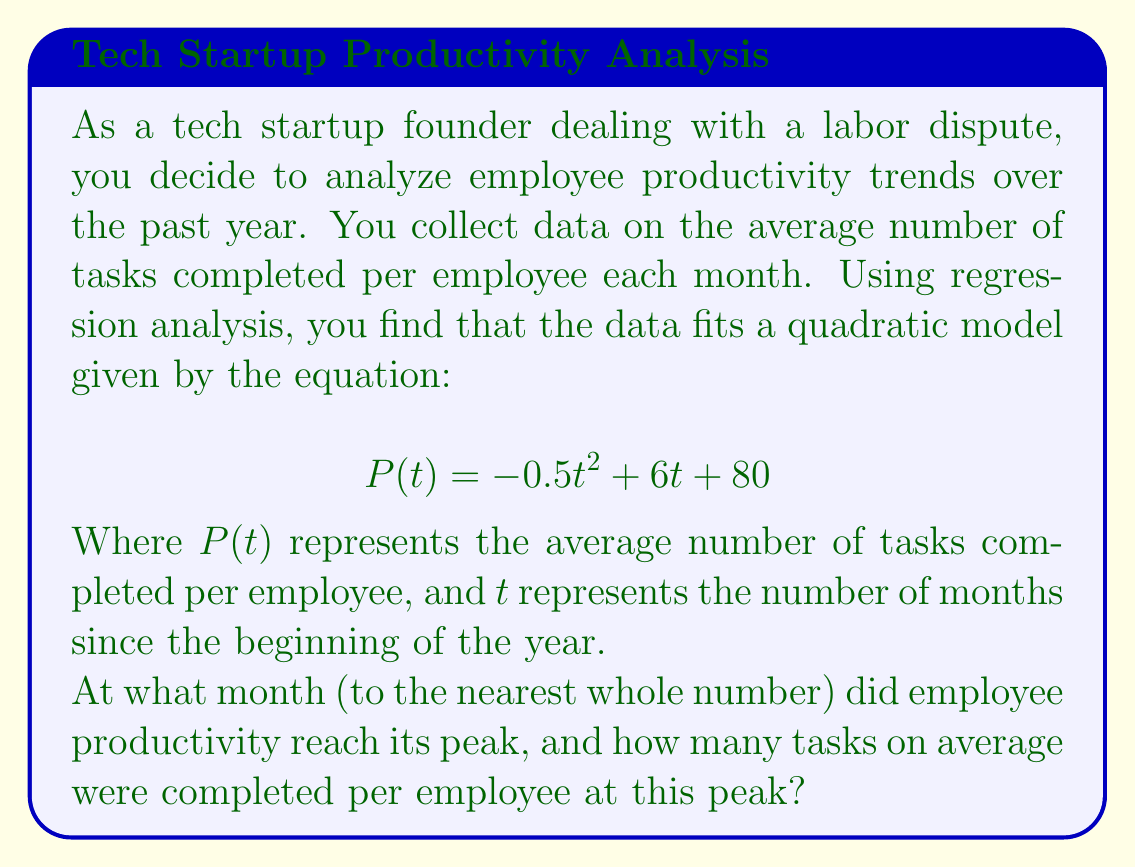Provide a solution to this math problem. To solve this problem, we need to follow these steps:

1. Find the vertex of the quadratic function, as this represents the peak of the parabola.

2. The general form of a quadratic function is $f(x) = ax^2 + bx + c$, where the vertex is given by $(-\frac{b}{2a}, f(-\frac{b}{2a}))$.

3. In our case, $a = -0.5$, $b = 6$, and $c = 80$.

4. To find the x-coordinate of the vertex (representing the month of peak productivity):
   
   $t = -\frac{b}{2a} = -\frac{6}{2(-0.5)} = \frac{6}{1} = 6$

5. To find the y-coordinate of the vertex (representing the peak number of tasks):
   
   $P(6) = -0.5(6)^2 + 6(6) + 80$
   $= -0.5(36) + 36 + 80$
   $= -18 + 36 + 80$
   $= 98$

6. Therefore, productivity peaked at 6 months (June, assuming January is month 0) with an average of 98 tasks completed per employee.
Answer: 6 months, 98 tasks 